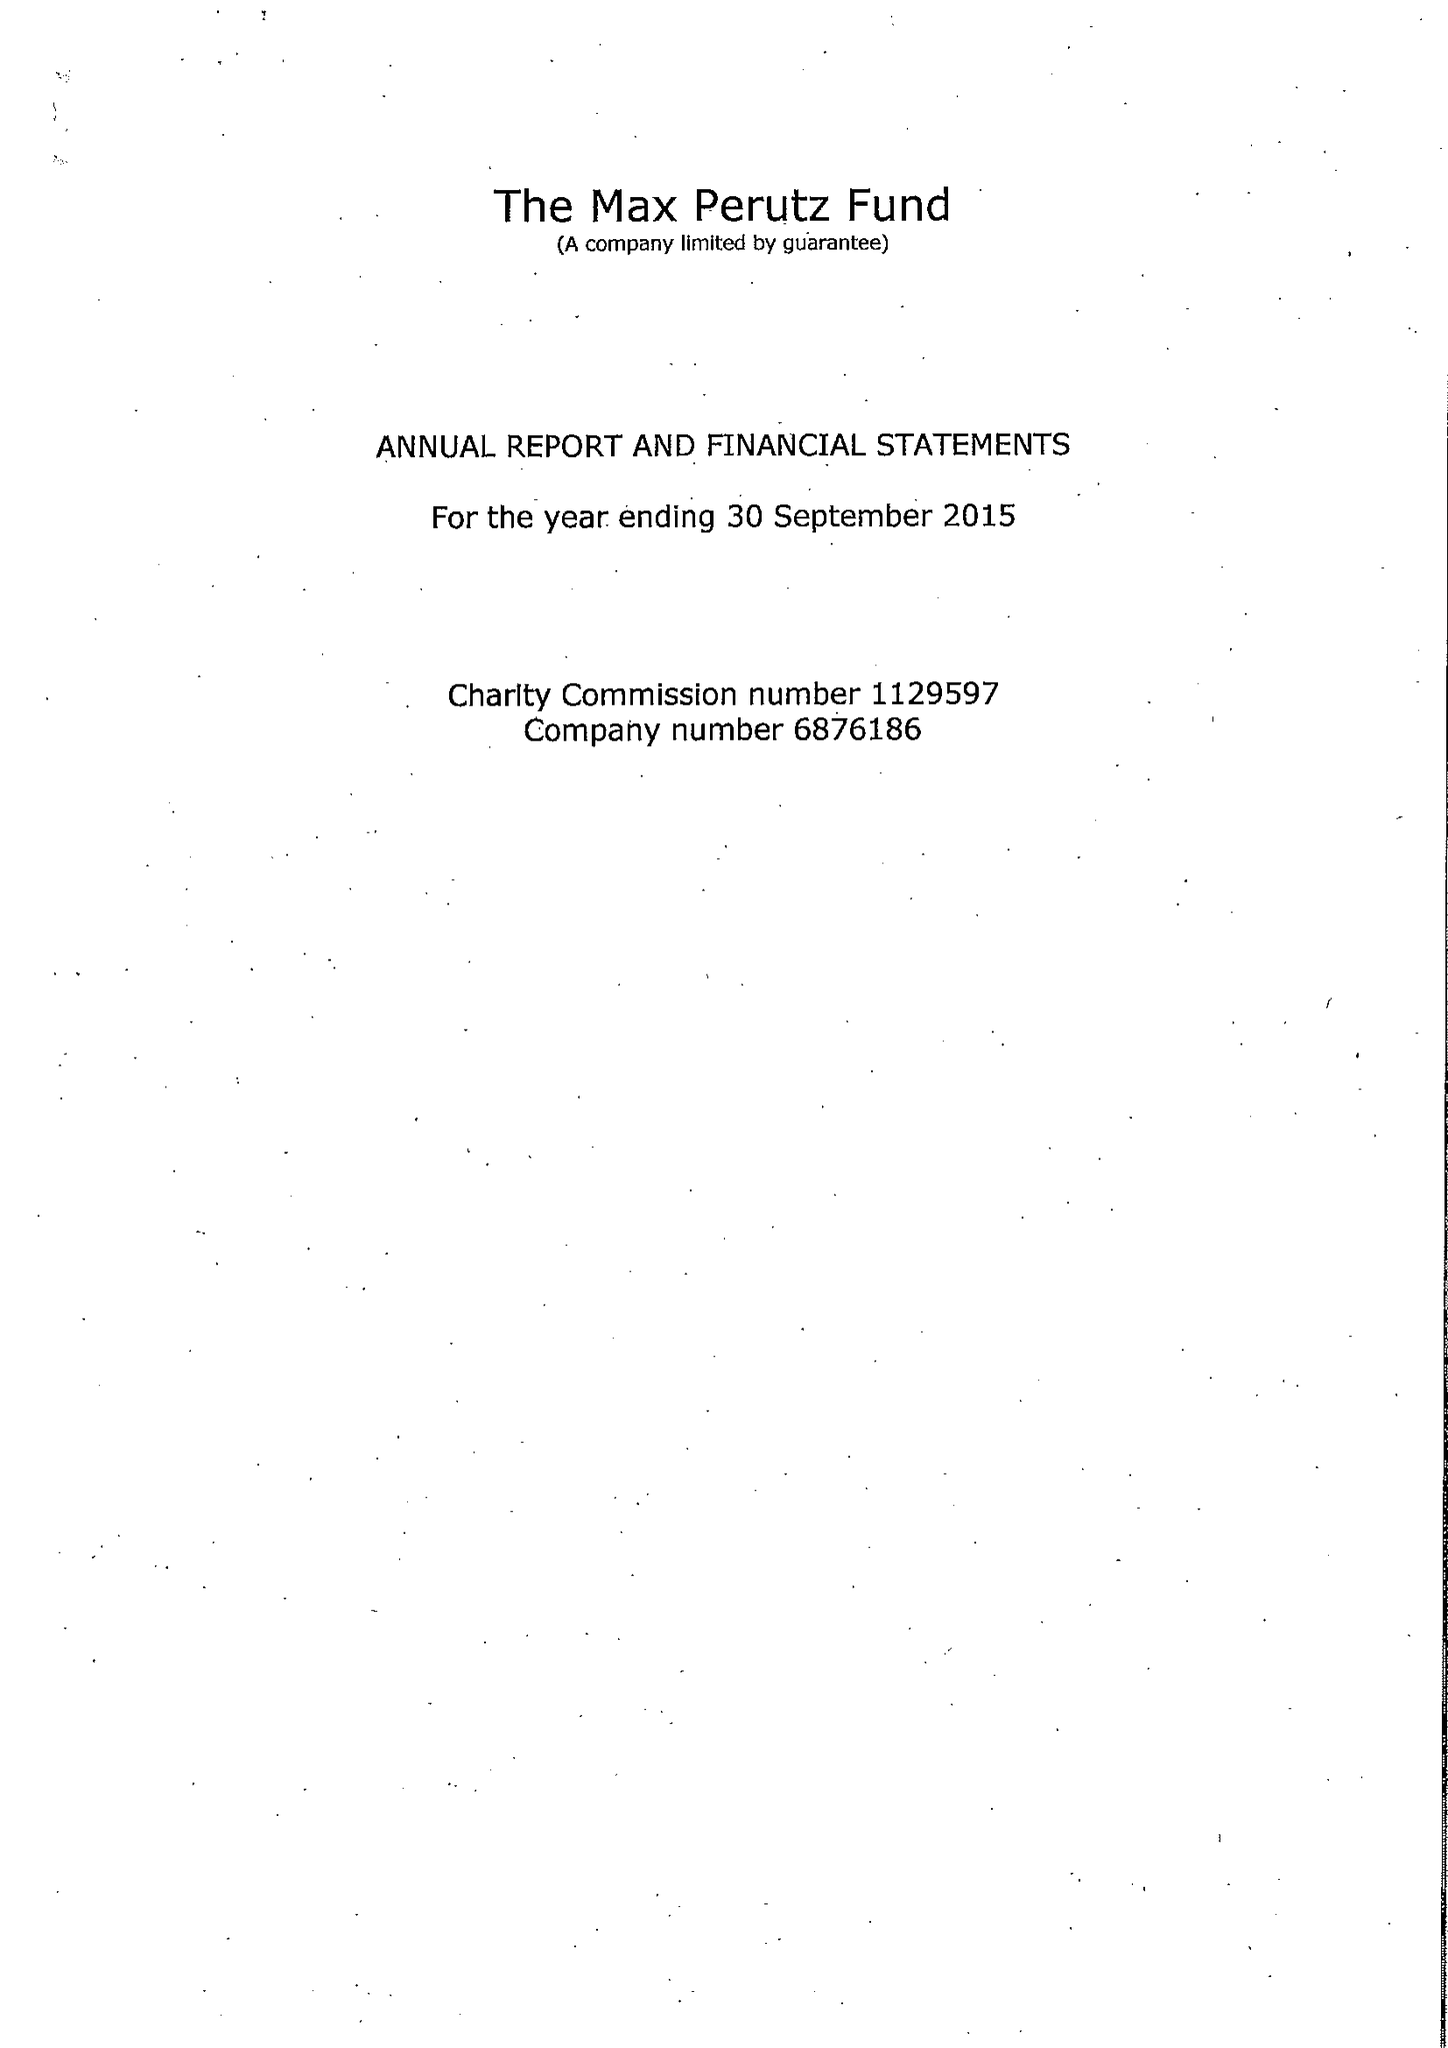What is the value for the address__post_town?
Answer the question using a single word or phrase. CAMBRIDGE 